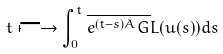Convert formula to latex. <formula><loc_0><loc_0><loc_500><loc_500>t \longmapsto \int _ { 0 } ^ { t } \overline { e ^ { ( t - s ) A } G } L ( u ( s ) ) d s</formula> 